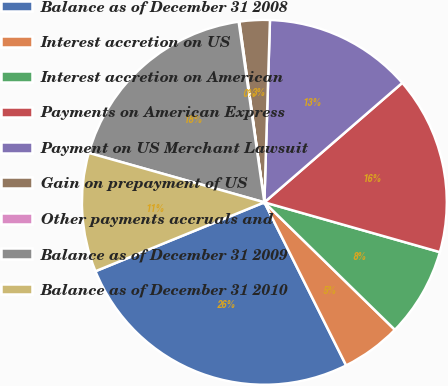Convert chart. <chart><loc_0><loc_0><loc_500><loc_500><pie_chart><fcel>Balance as of December 31 2008<fcel>Interest accretion on US<fcel>Interest accretion on American<fcel>Payments on American Express<fcel>Payment on US Merchant Lawsuit<fcel>Gain on prepayment of US<fcel>Other payments accruals and<fcel>Balance as of December 31 2009<fcel>Balance as of December 31 2010<nl><fcel>26.23%<fcel>5.29%<fcel>7.91%<fcel>15.76%<fcel>13.15%<fcel>2.68%<fcel>0.06%<fcel>18.38%<fcel>10.53%<nl></chart> 